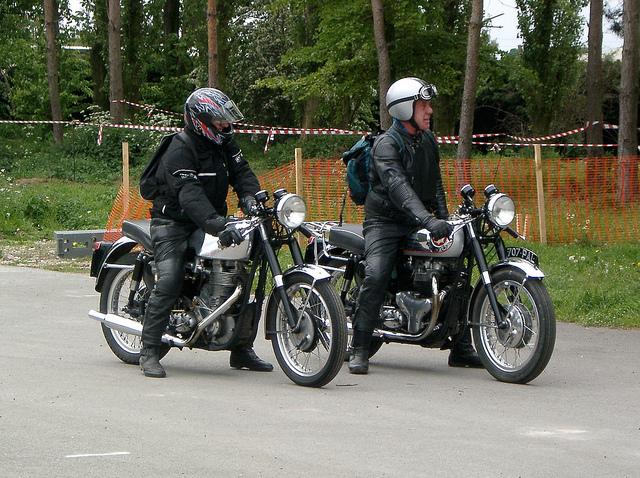Is this person driving around a curve?
Give a very brief answer. No. Which helmet is silver?
Give a very brief answer. One on right. Does he have facial hair?
Write a very short answer. No. Are the men riding motorcycles?
Quick response, please. Yes. Are the motorcycles moving?
Short answer required. No. What color is the fence?
Short answer required. Orange. How many motorcycles are there?
Be succinct. 2. 